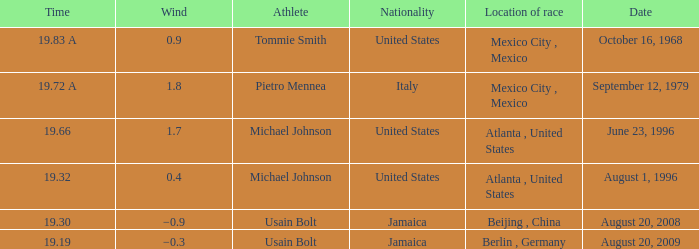Who was the athlete with a wind of 1.8? Pietro Mennea. Could you parse the entire table? {'header': ['Time', 'Wind', 'Athlete', 'Nationality', 'Location of race', 'Date'], 'rows': [['19.83 A', '0.9', 'Tommie Smith', 'United States', 'Mexico City , Mexico', 'October 16, 1968'], ['19.72 A', '1.8', 'Pietro Mennea', 'Italy', 'Mexico City , Mexico', 'September 12, 1979'], ['19.66', '1.7', 'Michael Johnson', 'United States', 'Atlanta , United States', 'June 23, 1996'], ['19.32', '0.4', 'Michael Johnson', 'United States', 'Atlanta , United States', 'August 1, 1996'], ['19.30', '−0.9', 'Usain Bolt', 'Jamaica', 'Beijing , China', 'August 20, 2008'], ['19.19', '−0.3', 'Usain Bolt', 'Jamaica', 'Berlin , Germany', 'August 20, 2009']]} 